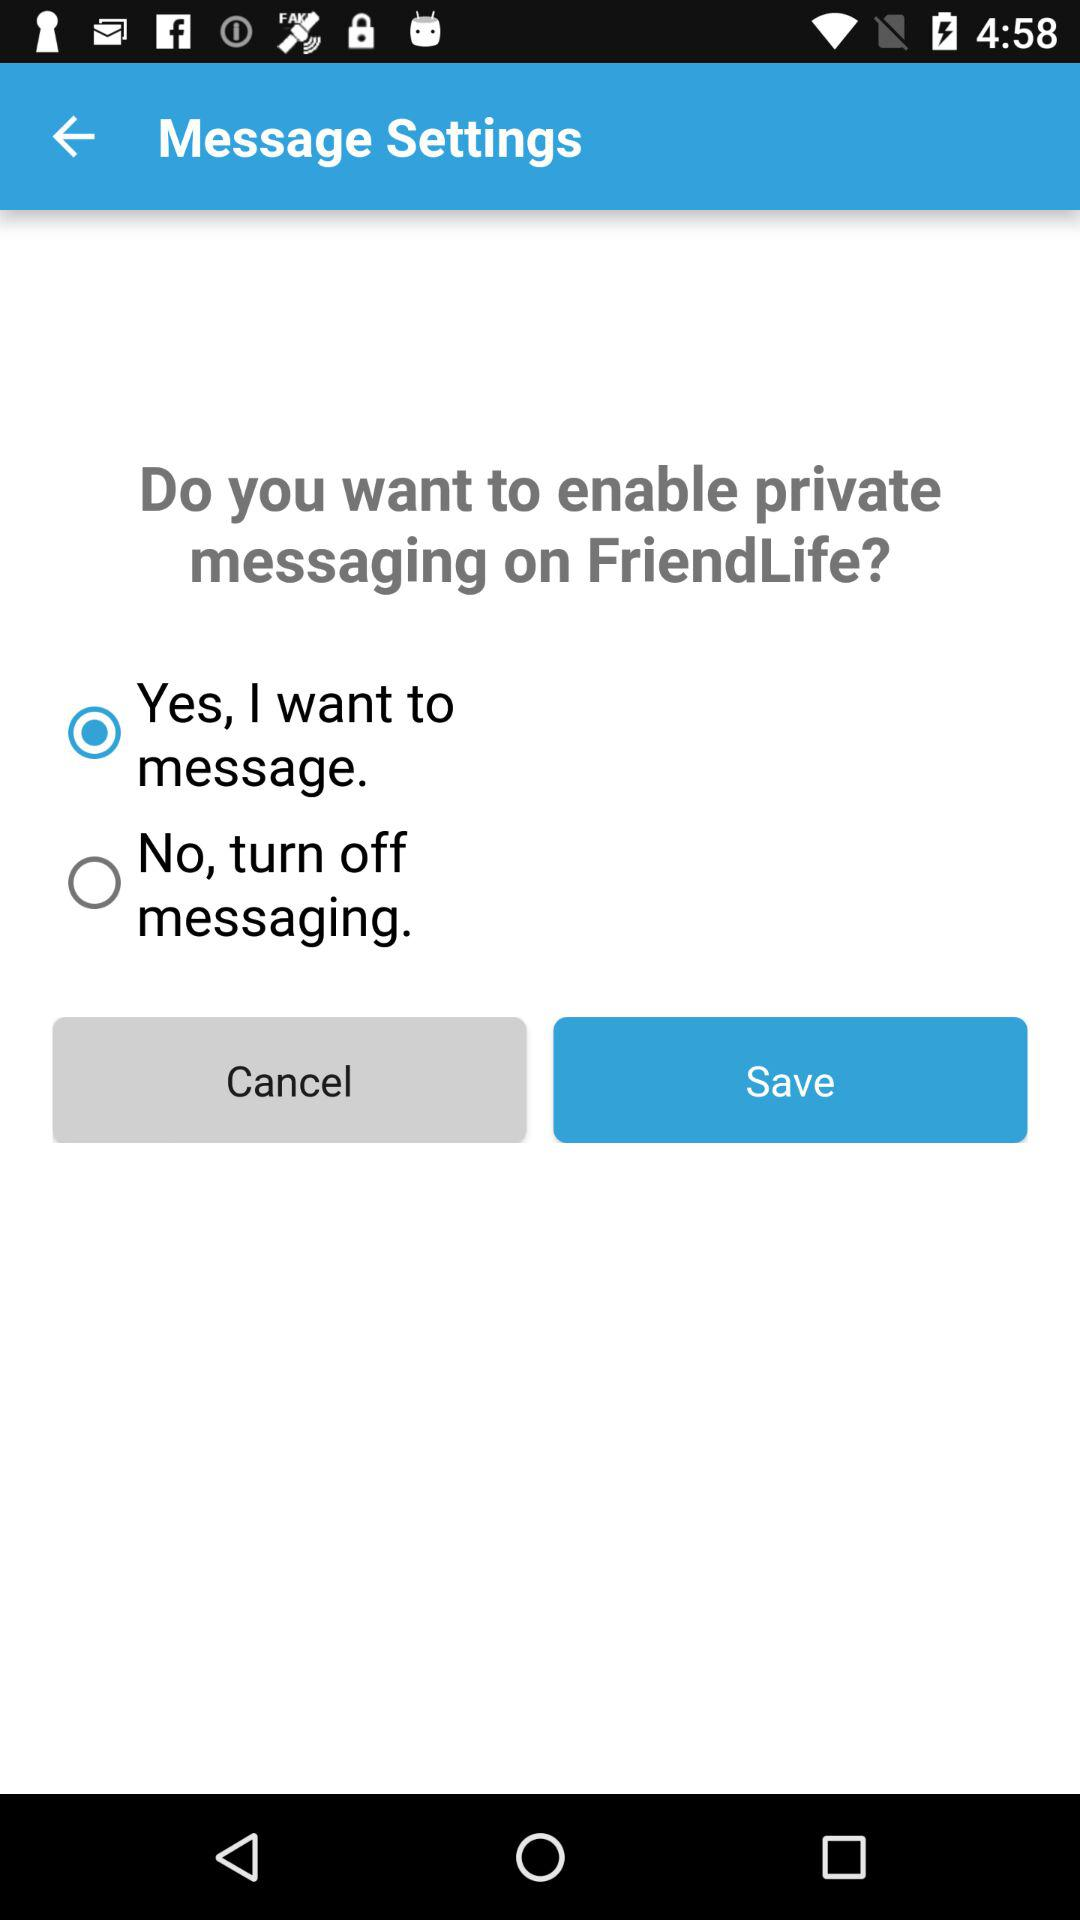Which is the selected radio button? The selected radio button is "Yes, I want to message". 